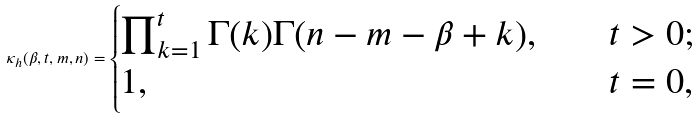Convert formula to latex. <formula><loc_0><loc_0><loc_500><loc_500>\kappa _ { h } ( \beta , t , m , n ) = \begin{cases} \prod _ { k = 1 } ^ { t } \Gamma ( k ) \Gamma ( n - m - \beta + k ) , \quad & t > 0 ; \\ 1 , \quad & t = 0 , \end{cases}</formula> 